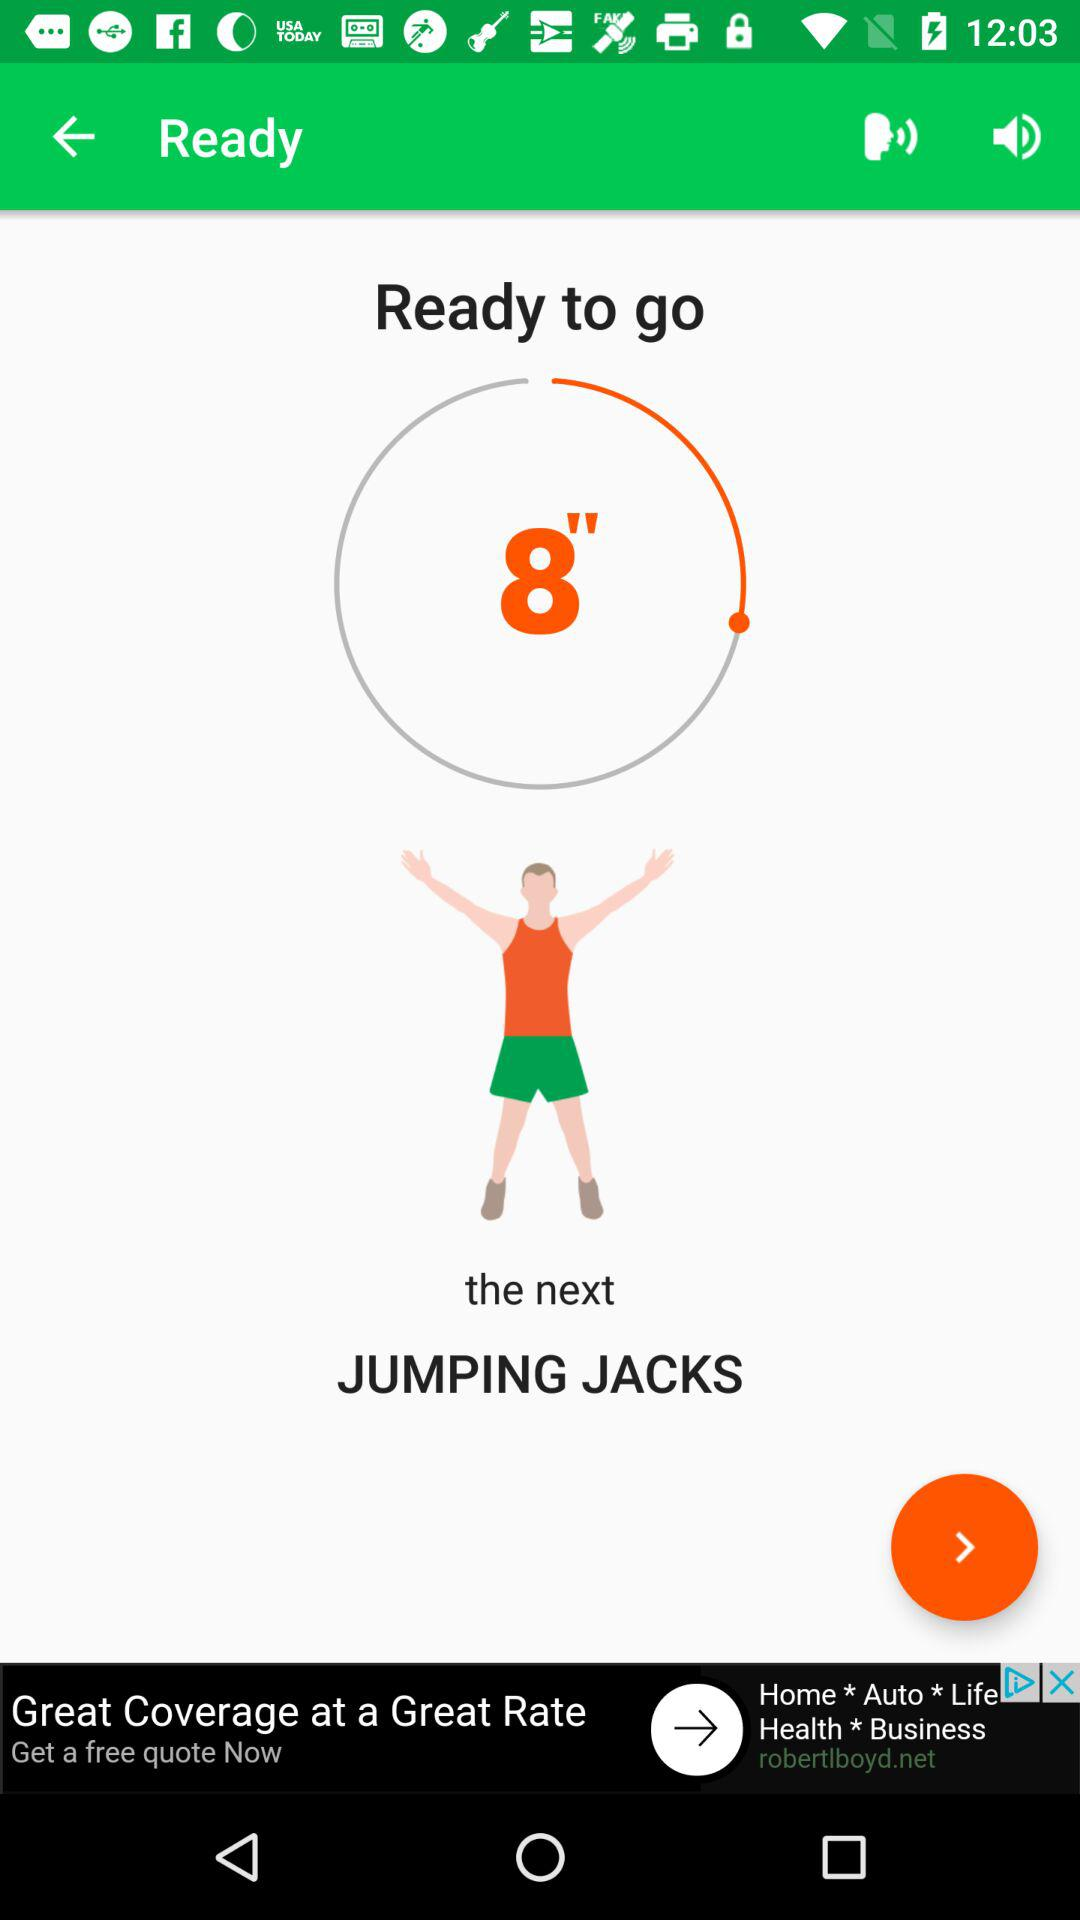How many volume states are there? The image displays a fitness application with a timer set to 8 seconds, preparing for the next exercise, which is jumping jacks. The question might be misinterpreted as it seems unrelated to the actual content of the image. Therefore, there are no 'volume states' visible in the image; the focus is on a workout timer and exercise instruction. 